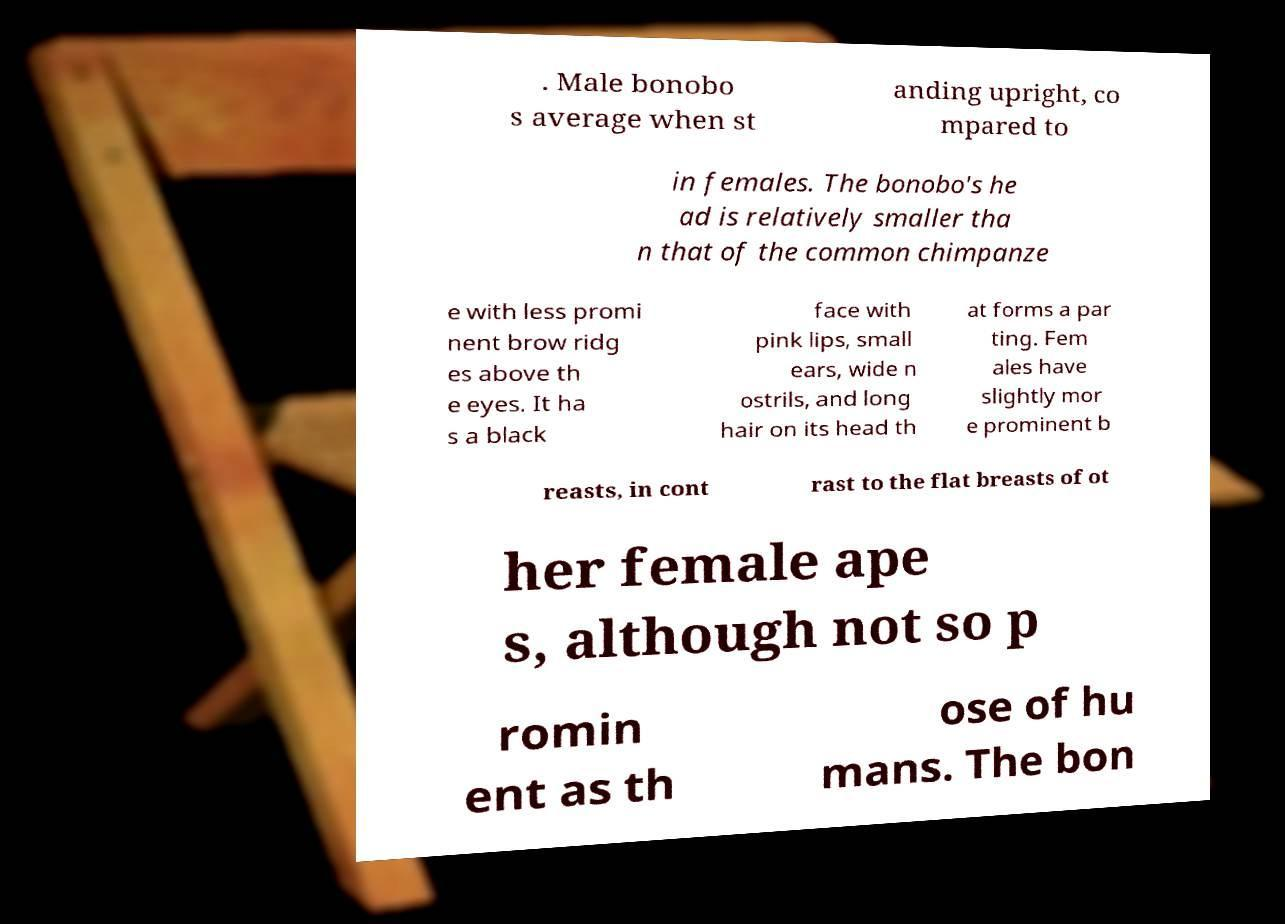For documentation purposes, I need the text within this image transcribed. Could you provide that? . Male bonobo s average when st anding upright, co mpared to in females. The bonobo's he ad is relatively smaller tha n that of the common chimpanze e with less promi nent brow ridg es above th e eyes. It ha s a black face with pink lips, small ears, wide n ostrils, and long hair on its head th at forms a par ting. Fem ales have slightly mor e prominent b reasts, in cont rast to the flat breasts of ot her female ape s, although not so p romin ent as th ose of hu mans. The bon 